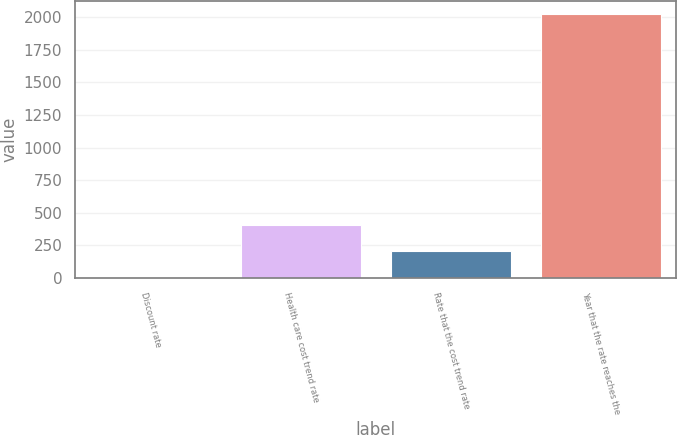<chart> <loc_0><loc_0><loc_500><loc_500><bar_chart><fcel>Discount rate<fcel>Health care cost trend rate<fcel>Rate that the cost trend rate<fcel>Year that the rate reaches the<nl><fcel>4<fcel>407.6<fcel>205.8<fcel>2022<nl></chart> 